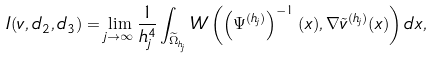<formula> <loc_0><loc_0><loc_500><loc_500>I ( v , d _ { 2 } , d _ { 3 } ) = \lim _ { j \rightarrow \infty } \frac { 1 } { h _ { j } ^ { 4 } } \int _ { \widetilde { \Omega } _ { h _ { j } } } W \left ( \left ( \Psi ^ { ( h _ { j } ) } \right ) ^ { - 1 } ( x ) , \nabla \tilde { v } ^ { ( h _ { j } ) } ( x ) \right ) d x ,</formula> 